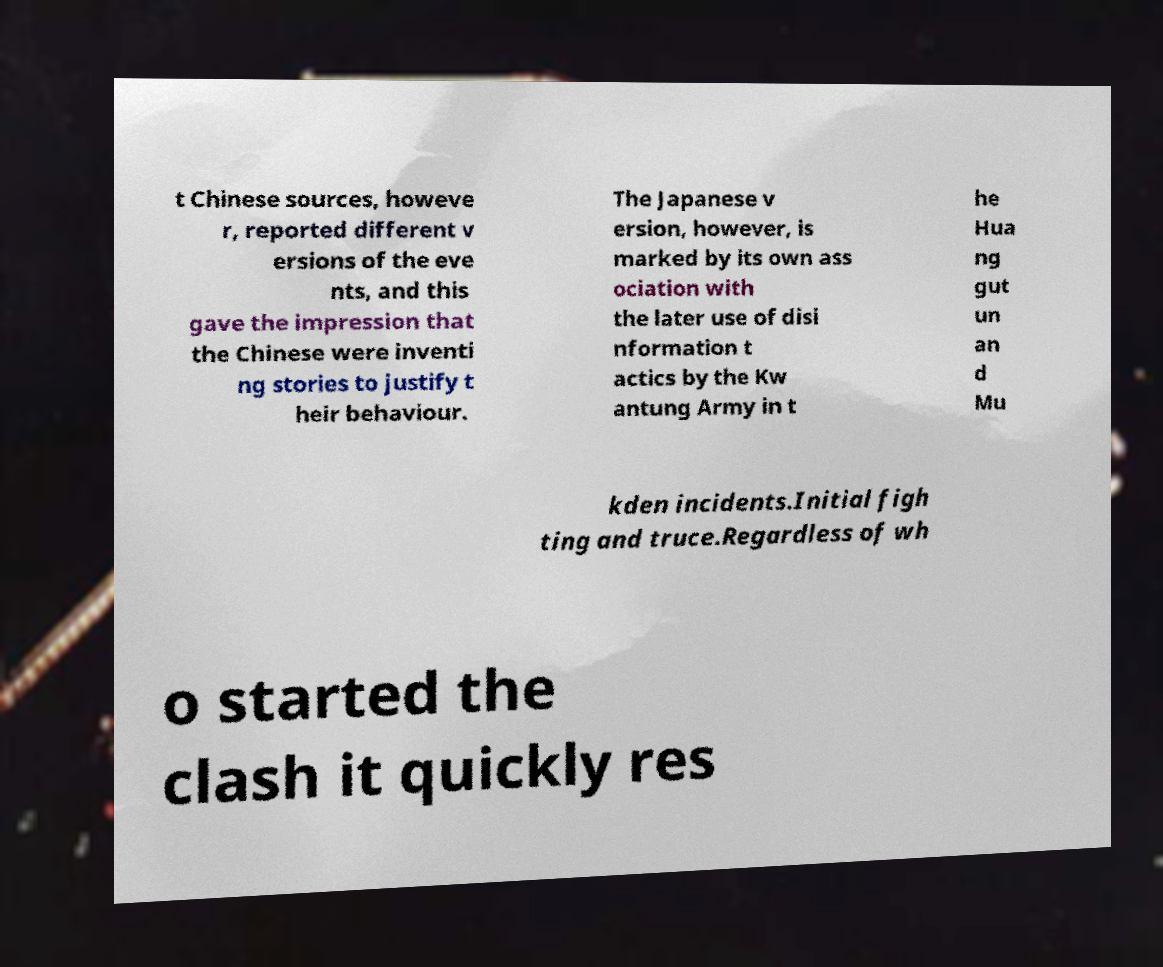Could you extract and type out the text from this image? t Chinese sources, howeve r, reported different v ersions of the eve nts, and this gave the impression that the Chinese were inventi ng stories to justify t heir behaviour. The Japanese v ersion, however, is marked by its own ass ociation with the later use of disi nformation t actics by the Kw antung Army in t he Hua ng gut un an d Mu kden incidents.Initial figh ting and truce.Regardless of wh o started the clash it quickly res 